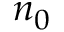Convert formula to latex. <formula><loc_0><loc_0><loc_500><loc_500>n _ { 0 }</formula> 